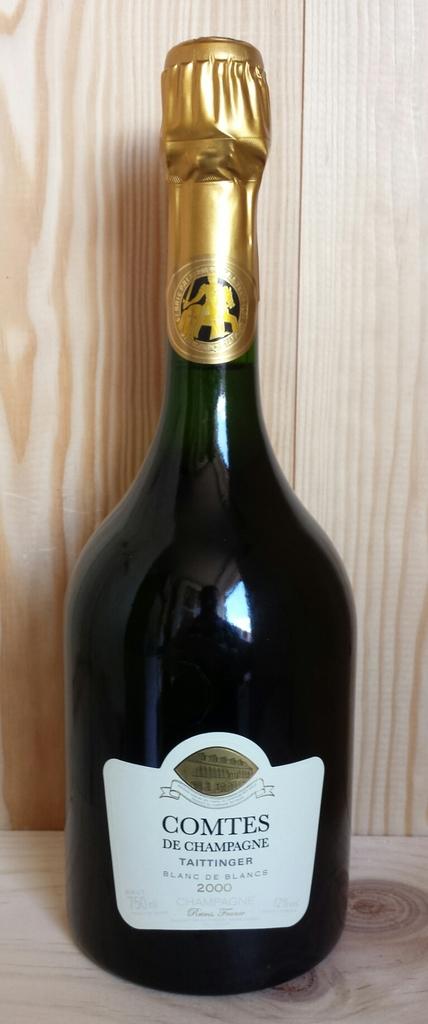What brand of champagne is this?
Your response must be concise. Comtes. What year was the wine made?
Your answer should be very brief. 2000. 